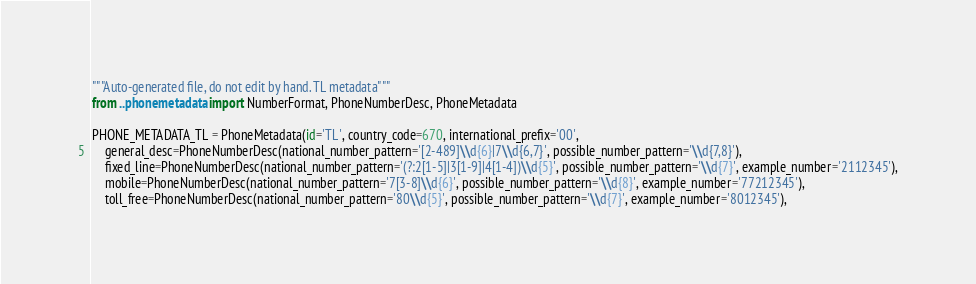<code> <loc_0><loc_0><loc_500><loc_500><_Python_>"""Auto-generated file, do not edit by hand. TL metadata"""
from ..phonemetadata import NumberFormat, PhoneNumberDesc, PhoneMetadata

PHONE_METADATA_TL = PhoneMetadata(id='TL', country_code=670, international_prefix='00',
    general_desc=PhoneNumberDesc(national_number_pattern='[2-489]\\d{6}|7\\d{6,7}', possible_number_pattern='\\d{7,8}'),
    fixed_line=PhoneNumberDesc(national_number_pattern='(?:2[1-5]|3[1-9]|4[1-4])\\d{5}', possible_number_pattern='\\d{7}', example_number='2112345'),
    mobile=PhoneNumberDesc(national_number_pattern='7[3-8]\\d{6}', possible_number_pattern='\\d{8}', example_number='77212345'),
    toll_free=PhoneNumberDesc(national_number_pattern='80\\d{5}', possible_number_pattern='\\d{7}', example_number='8012345'),</code> 